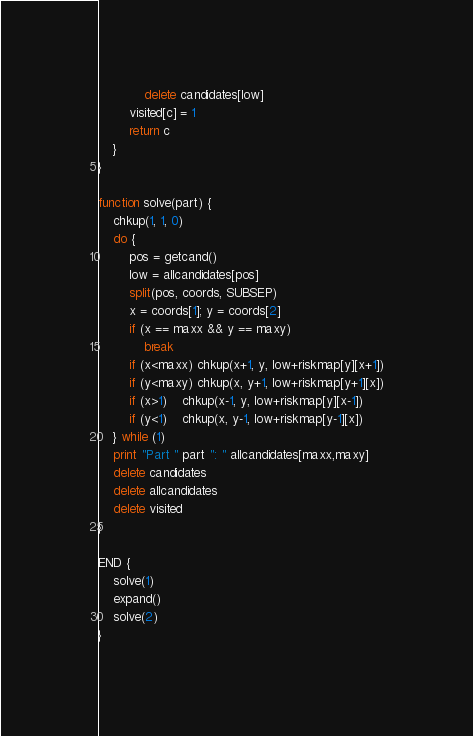<code> <loc_0><loc_0><loc_500><loc_500><_Awk_>            delete candidates[low]
        visited[c] = 1
        return c
    }
}

function solve(part) {
    chkup(1, 1, 0)
    do {
        pos = getcand()
        low = allcandidates[pos]
        split(pos, coords, SUBSEP)
        x = coords[1]; y = coords[2]
        if (x == maxx && y == maxy)
            break
        if (x<maxx) chkup(x+1, y, low+riskmap[y][x+1])
        if (y<maxy) chkup(x, y+1, low+riskmap[y+1][x])
        if (x>1)    chkup(x-1, y, low+riskmap[y][x-1])
        if (y<1)    chkup(x, y-1, low+riskmap[y-1][x])
    } while (1)
    print "Part " part ": " allcandidates[maxx,maxy]
    delete candidates
    delete allcandidates
    delete visited
}    

END {
    solve(1)
    expand()
    solve(2)
}
</code> 